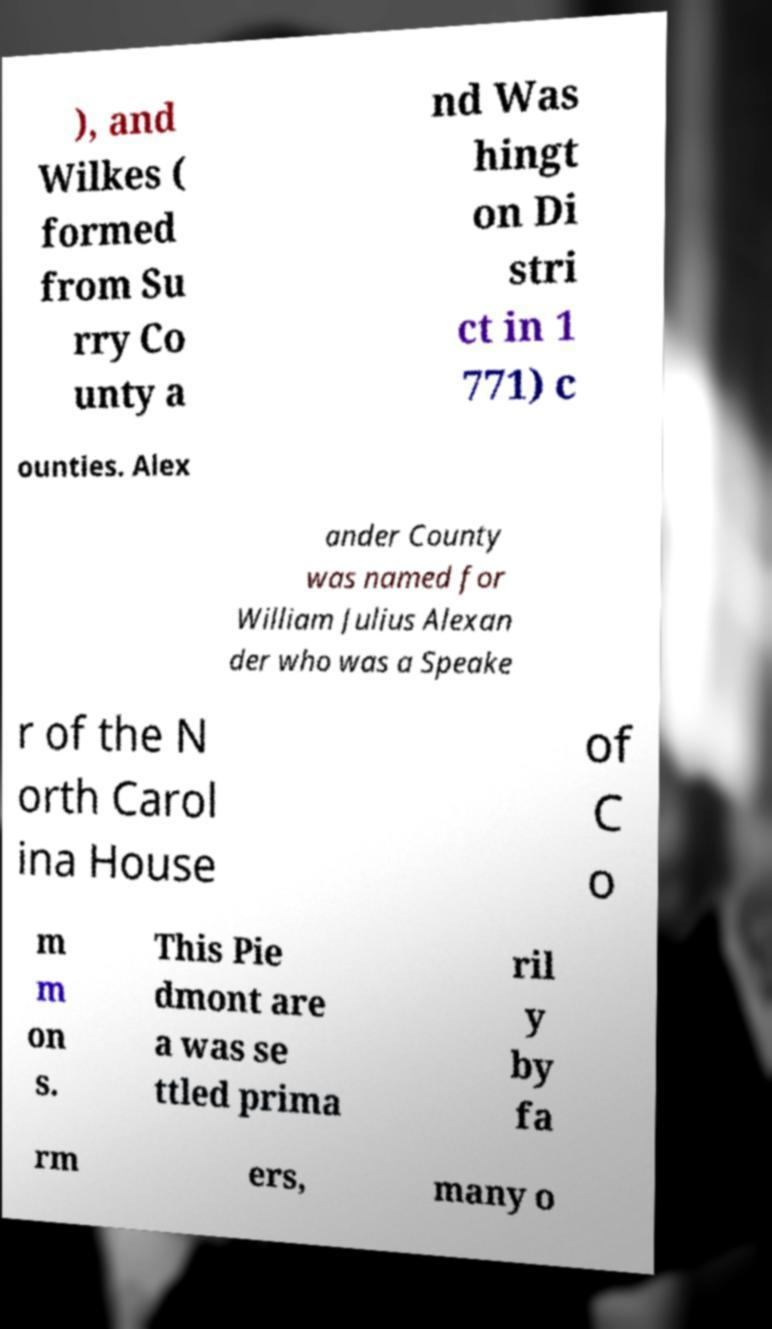For documentation purposes, I need the text within this image transcribed. Could you provide that? ), and Wilkes ( formed from Su rry Co unty a nd Was hingt on Di stri ct in 1 771) c ounties. Alex ander County was named for William Julius Alexan der who was a Speake r of the N orth Carol ina House of C o m m on s. This Pie dmont are a was se ttled prima ril y by fa rm ers, many o 